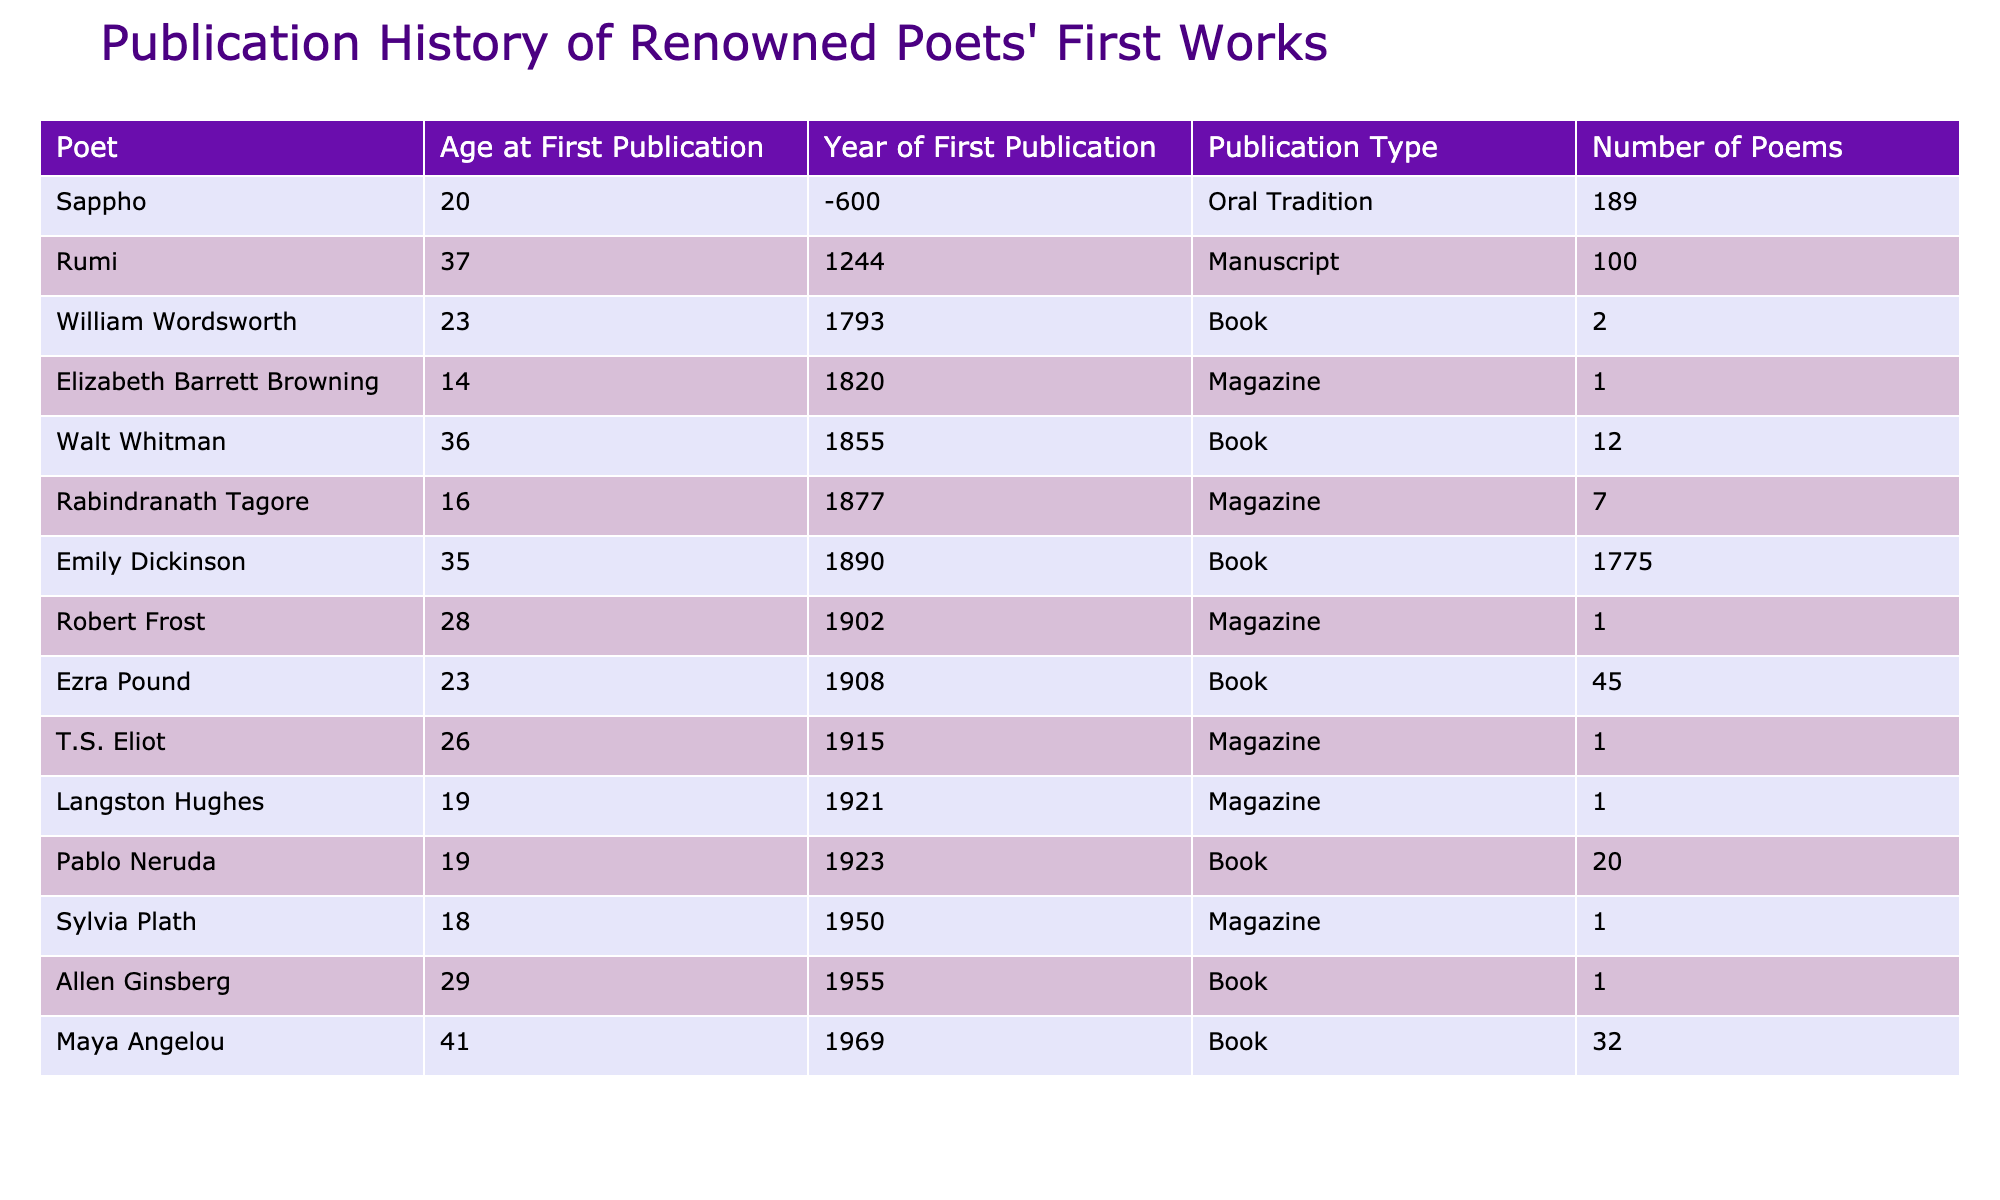What was the year of Emily Dickinson's first publication? From the table, we find Emily Dickinson listed under the column "Year of First Publication" with the value 1890.
Answer: 1890 What type of publication did Sylvia Plath use for her first work? The table indicates that Sylvia Plath's first work was published in a "Magazine."
Answer: Magazine Who is the youngest poet listed, and how old was he at his first publication? The table shows that Elizabeth Barrett Browning was the youngest at 14 years old at her first publication.
Answer: Elizabeth Barrett Browning, 14 How many poems did Walt Whitman include in his first publication? By looking at the "Number of Poems" column, we see that Walt Whitman had 12 poems in his first publication.
Answer: 12 Which poet had the highest number of poems in their first work, and what was that number? By comparing the "Number of Poems" column, Rumi had the highest number with 100 poems.
Answer: Rumi, 100 What is the difference in age at first publication between Emily Dickinson and Maya Angelou? Emily Dickinson was 35 years old, and Maya Angelou was 41 years old at their first publication, so the difference is 41 - 35 = 6 years.
Answer: 6 years What was the average age at first publication of the poets listed? We sum the ages at first publication (35 + 18 + 19 + 19 + 36 + 41 + 28 + 23 + 26 + 14 + 29 + 37 + 23 + 16 + 20) =  21.93, then divide by the number of poets (15) which gives us approximately 27.76 years.
Answer: Approximately 27.76 years Does any poet have their first work published in an oral tradition? The table shows that Sappho's first work was indeed published in "Oral Tradition," confirming the existence of oral tradition in the data.
Answer: Yes Which poet had their first publication before the 20th century? By checking the "Year of First Publication" column, we find Walt Whitman (1855), William Wordsworth (1793), and Sappho (-600) published before the 20th century.
Answer: Walt Whitman, William Wordsworth, Sappho What can you say about the publication types of the youngest poets? Looking at the ages of the two youngest poets, Sylvia Plath (Magazine) and Elizabeth Barrett Browning (Magazine), we see that both used magazines for their first publications.
Answer: Both used magazines 